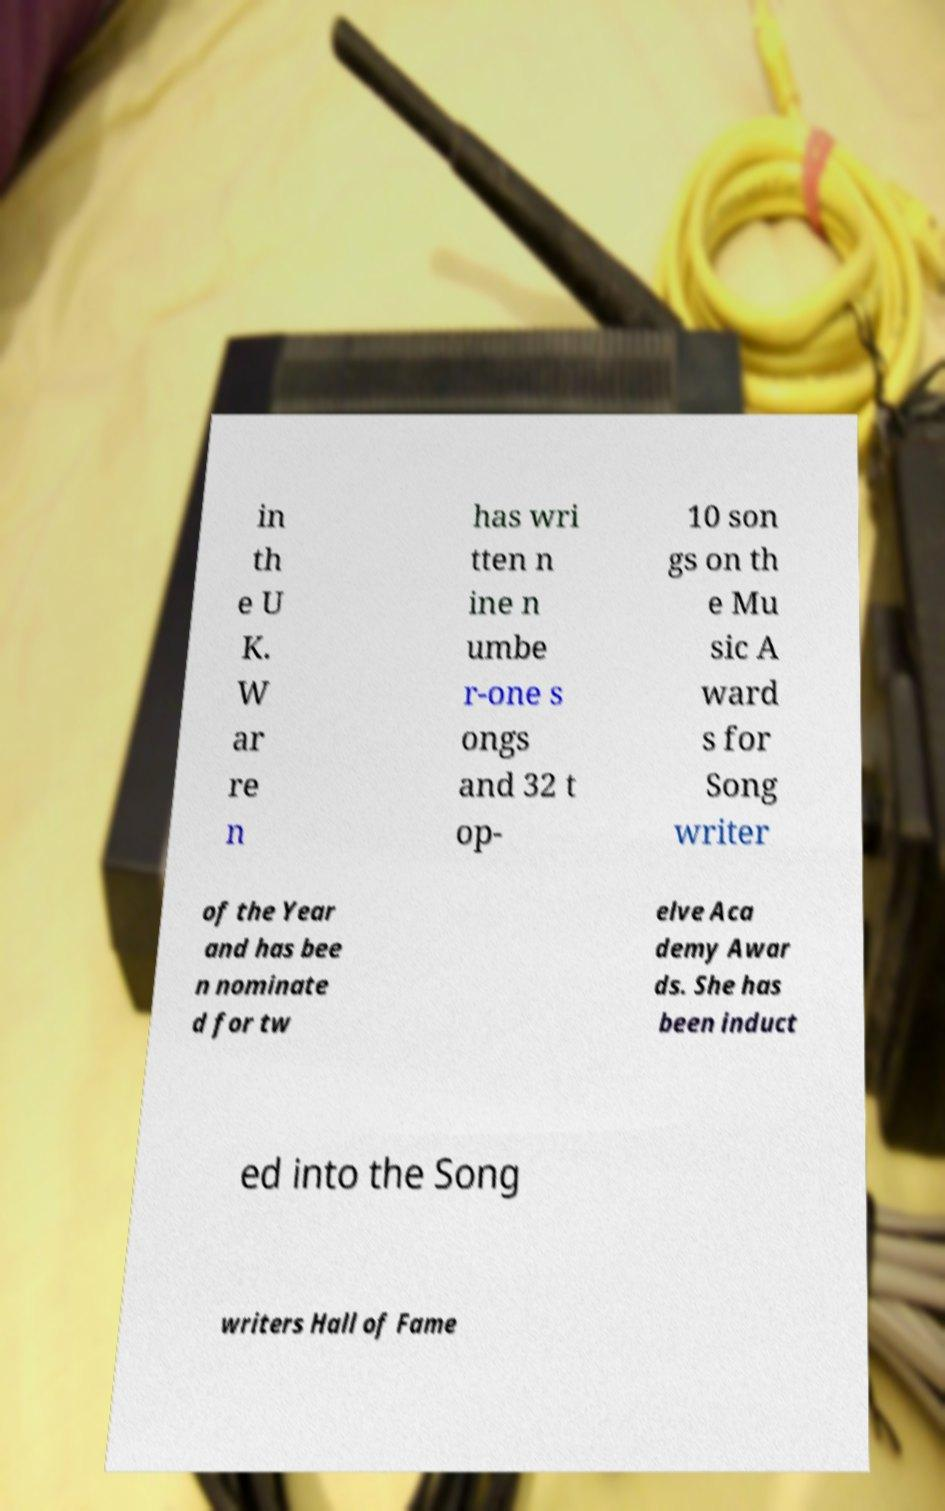Please read and relay the text visible in this image. What does it say? in th e U K. W ar re n has wri tten n ine n umbe r-one s ongs and 32 t op- 10 son gs on th e Mu sic A ward s for Song writer of the Year and has bee n nominate d for tw elve Aca demy Awar ds. She has been induct ed into the Song writers Hall of Fame 